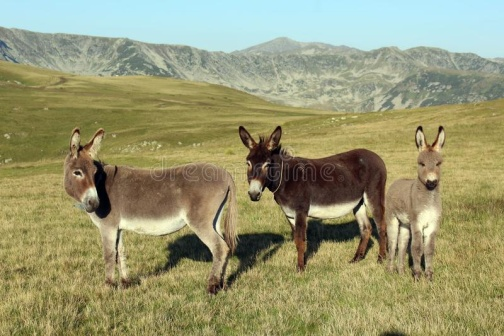Analyze the image in a comprehensive and detailed manner. In the image, three donkeys stand in a grassy field. The left donkey is gray mixed with white, the middle one is brown, and the right one is gray. They all face the camera, appearing motionless, set against a backdrop of rugged, greenish, rocky mountains. The serene ambiance is accentuated by the high-altitude mountainous landscape in the background. The donkeys are positioned in the foreground, with the majestic, distant mountains providing a picturesque and rugged background. This detailed description ensures that all visual elements are thoroughly covered, providing an accurate and comprehensive analysis of the scene depicted in the image. 